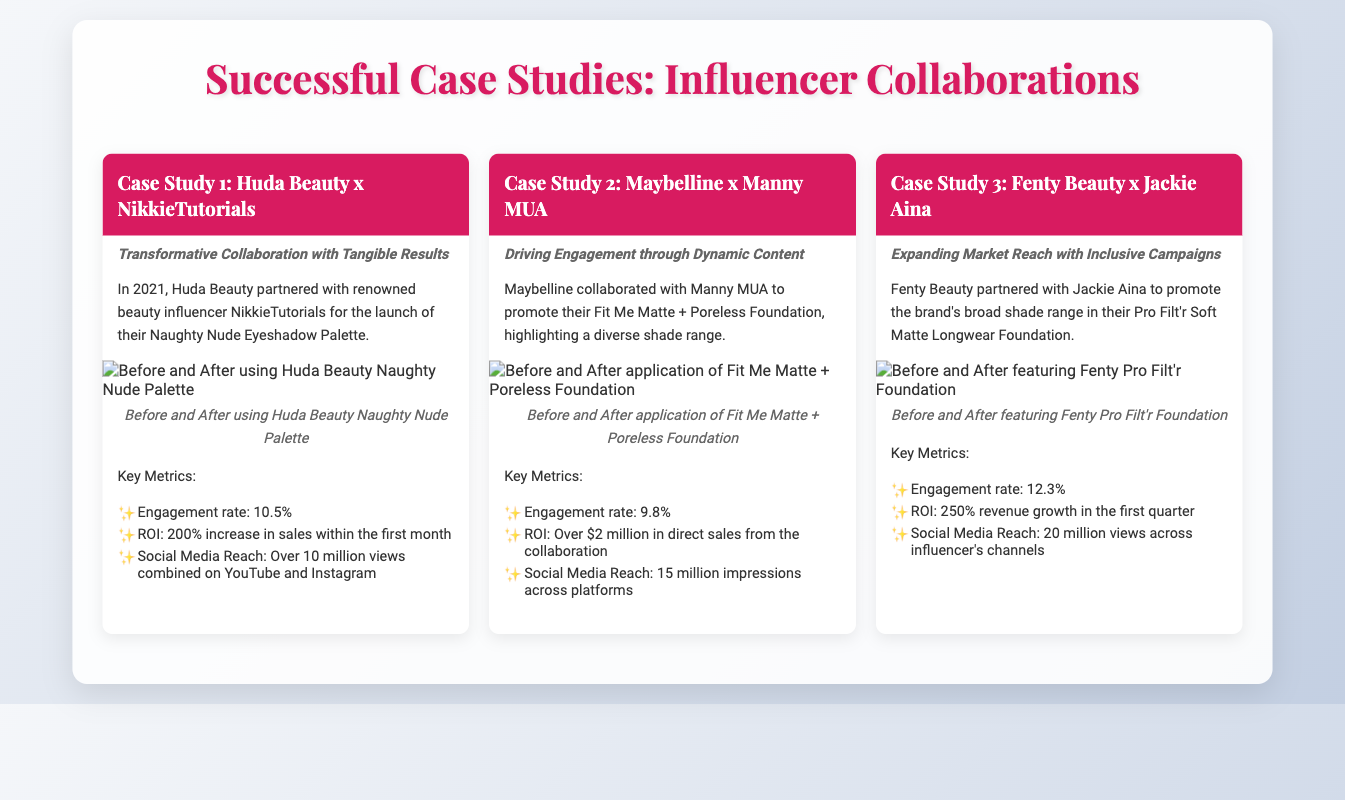What is the name of the first case study? The title of the first case study highlights the collaboration between Huda Beauty and NikkieTutorials.
Answer: Huda Beauty x NikkieTutorials What is the engagement rate for the collaboration with Manny MUA? The engagement rate provided in the metrics for the Maybelline x Manny MUA case study is 9.8%.
Answer: 9.8% What percentage increase in sales did the Huda Beauty collaboration achieve? The ROI for the Huda Beauty case study indicates a 200% increase in sales within the first month.
Answer: 200% How many million views did the Fenty Beauty collaboration achieve? The Fenty Beauty case study mentions that there were 20 million views across the influencer's channels.
Answer: 20 million Which influencer was involved in promoting the Pro Filt'r Foundation? The document names Jackie Aina as the influencer who collaborated with Fenty Beauty for this product.
Answer: Jackie Aina What type of content was highlighted in the Maybelline collaboration? The case study discusses the promotion of a diverse shade range for the Fit Me Matte + Poreless Foundation.
Answer: Diverse shade range What was the total ROI from the Maybelline and Manny MUA collaboration? The document specifies that the collaboration resulted in over $2 million in direct sales.
Answer: Over $2 million What year did the Huda Beauty x NikkieTutorials collaboration take place? According to the text, the collaboration occurred in 2021.
Answer: 2021 